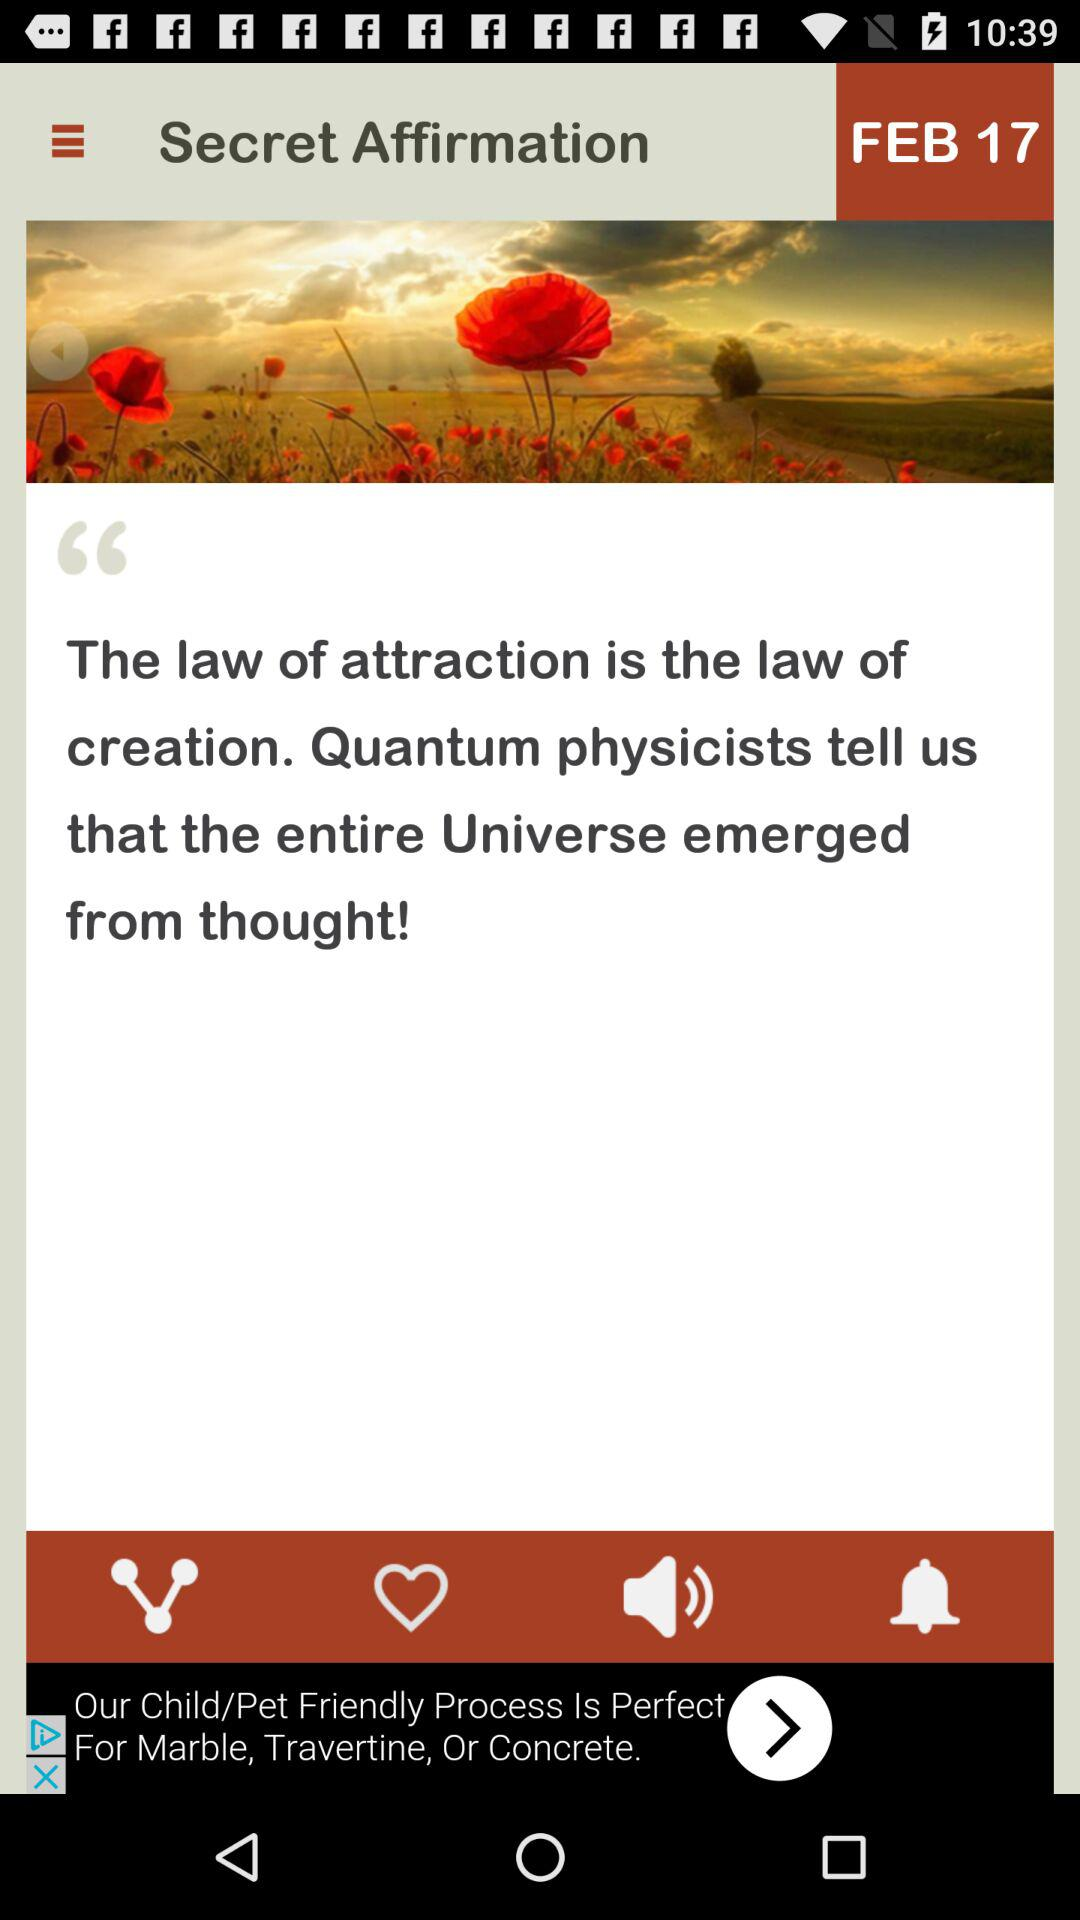What is the mentioned date? The mentioned date is February 17. 